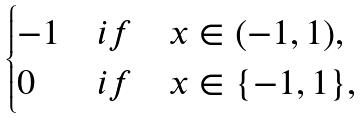Convert formula to latex. <formula><loc_0><loc_0><loc_500><loc_500>\begin{cases} - 1 & i f \quad x \in ( - 1 , 1 ) , \\ 0 & i f \quad x \in \{ - 1 , 1 \} , \end{cases}</formula> 